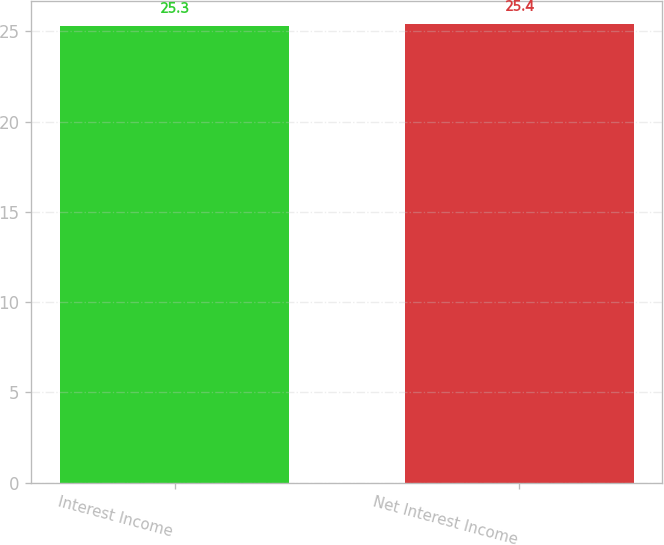Convert chart. <chart><loc_0><loc_0><loc_500><loc_500><bar_chart><fcel>Interest Income<fcel>Net Interest Income<nl><fcel>25.3<fcel>25.4<nl></chart> 